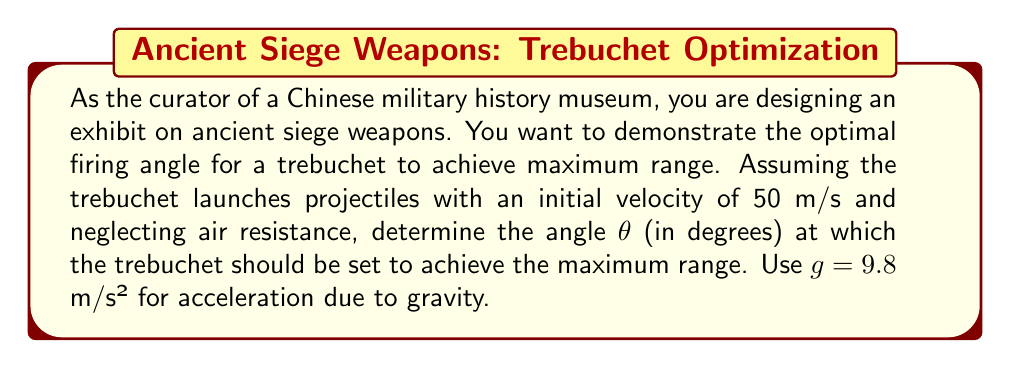Can you solve this math problem? To solve this problem, we'll use the principles of projectile motion and trigonometry.

1) The range (R) of a projectile launched at an angle θ with initial velocity v₀ is given by:

   $$R = \frac{v_0^2 \sin(2\theta)}{g}$$

2) To find the maximum range, we need to maximize the value of sin(2θ). The maximum value of sine is 1, which occurs when its argument is 90°.

3) Therefore, for maximum range:

   $$2\theta = 90°$$
   $$\theta = 45°$$

4) We can verify this mathematically by differentiating the range equation with respect to θ and setting it to zero:

   $$\frac{dR}{d\theta} = \frac{v_0^2}{g} \cdot 2\cos(2\theta) = 0$$

5) This equation is satisfied when cos(2θ) = 0, which occurs when 2θ = 90°, confirming our previous result.

6) We can also visualize this using Asymptote:

[asy]
import graph;
size(200,150);
real f(real x) {return sin(2*x);}
draw(graph(f,0,pi/2));
draw((0,0)--(pi/2,0),arrow=Arrow(TeXHead));
draw((0,0)--(0,1),arrow=Arrow(TeXHead));
label("$\theta$",(pi/2,0),SE);
label("$\sin(2\theta)$",(0,1),NW);
draw((pi/4,0)--(pi/4,f(pi/4)),dashed);
dot((pi/4,f(pi/4)));
label("45°",(pi/4,0),S);
[/asy]

This graph shows that sin(2θ) reaches its maximum value at θ = 45°.

Therefore, to achieve maximum range, the trebuchet should be set at an angle of 45° to the horizontal.
Answer: The optimal angle for maximum range of the trebuchet is $45°$. 